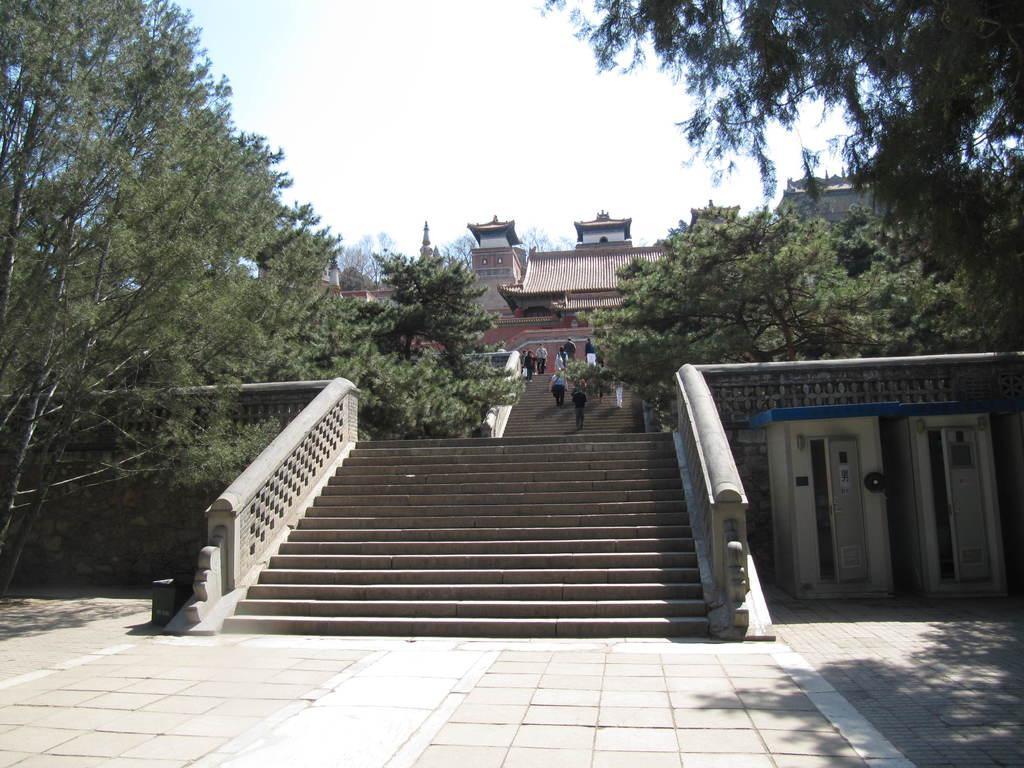What is the main feature in the center of the image? There are stairs in the center of the image. What are the people in the image doing? People are climbing the stairs. What type of natural elements can be seen in the image? There are trees visible in the image. What can be seen in the background of the image? There are buildings and the sky visible in the background of the image. Can you tell me how many caves are visible in the image? There are no caves present in the image. What type of lawyer is standing at the top of the stairs in the image? There is no lawyer present in the image; it only shows people climbing the stairs. 